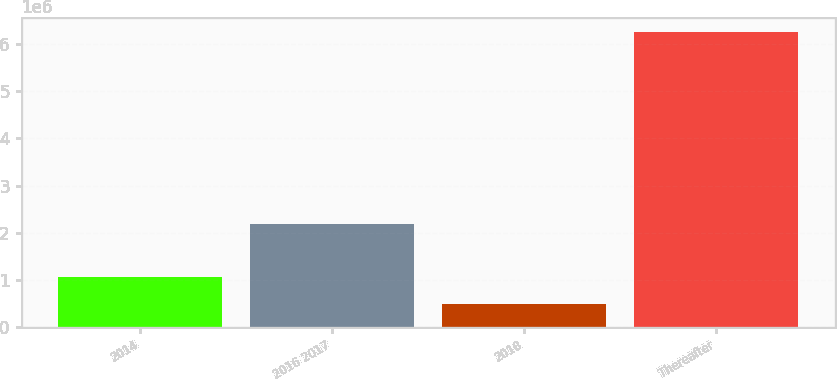Convert chart. <chart><loc_0><loc_0><loc_500><loc_500><bar_chart><fcel>2014<fcel>2016 2017<fcel>2018<fcel>Thereafter<nl><fcel>1.06823e+06<fcel>2.18343e+06<fcel>492500<fcel>6.24982e+06<nl></chart> 